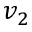Convert formula to latex. <formula><loc_0><loc_0><loc_500><loc_500>v _ { 2 }</formula> 